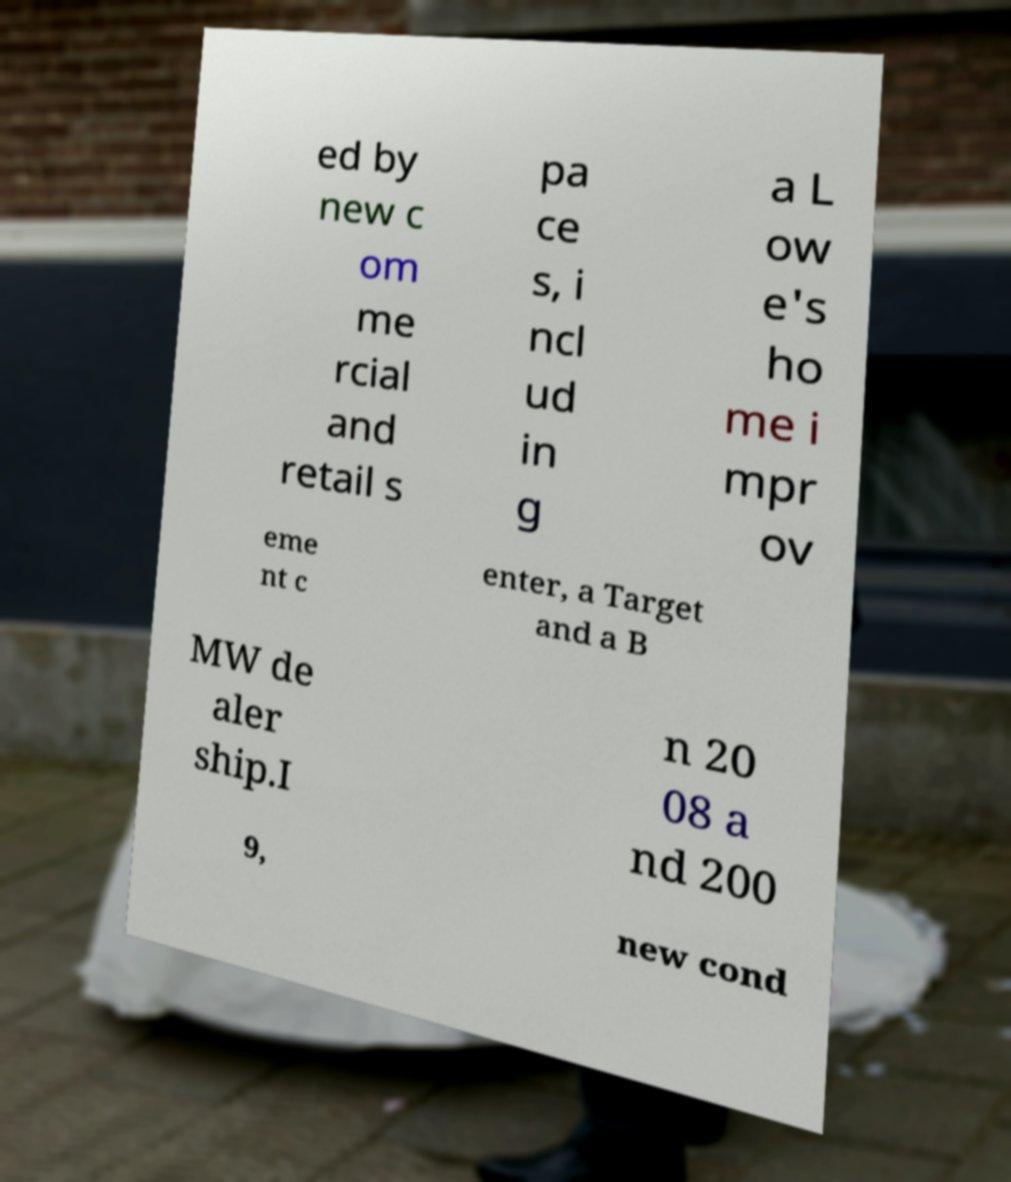Could you extract and type out the text from this image? ed by new c om me rcial and retail s pa ce s, i ncl ud in g a L ow e's ho me i mpr ov eme nt c enter, a Target and a B MW de aler ship.I n 20 08 a nd 200 9, new cond 